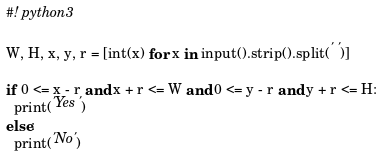<code> <loc_0><loc_0><loc_500><loc_500><_Python_>#! python3

W, H, x, y, r = [int(x) for x in input().strip().split(' ')]

if 0 <= x - r and x + r <= W and 0 <= y - r and y + r <= H:
  print('Yes')
else:
  print('No')</code> 